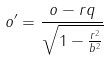Convert formula to latex. <formula><loc_0><loc_0><loc_500><loc_500>o ^ { \prime } = \frac { o - r q } { \sqrt { 1 - \frac { r ^ { 2 } } { b ^ { 2 } } } }</formula> 